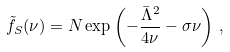<formula> <loc_0><loc_0><loc_500><loc_500>\tilde { f } _ { S } ( \nu ) = N \exp \left ( - \frac { \bar { \Lambda } ^ { 2 } } { 4 \nu } - \sigma \nu \right ) \, ,</formula> 